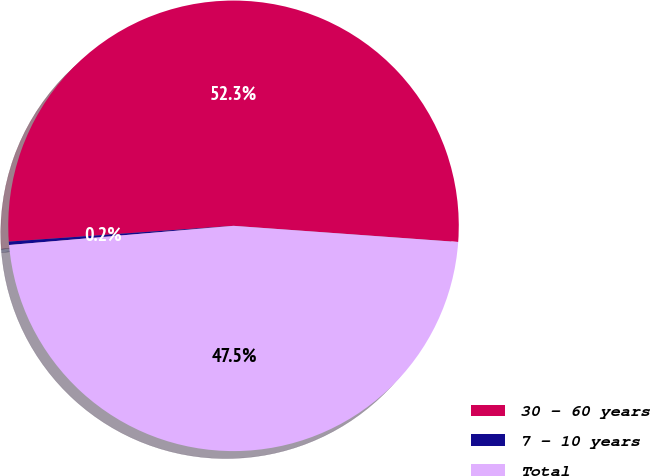<chart> <loc_0><loc_0><loc_500><loc_500><pie_chart><fcel>30 - 60 years<fcel>7 - 10 years<fcel>Total<nl><fcel>52.26%<fcel>0.24%<fcel>47.5%<nl></chart> 